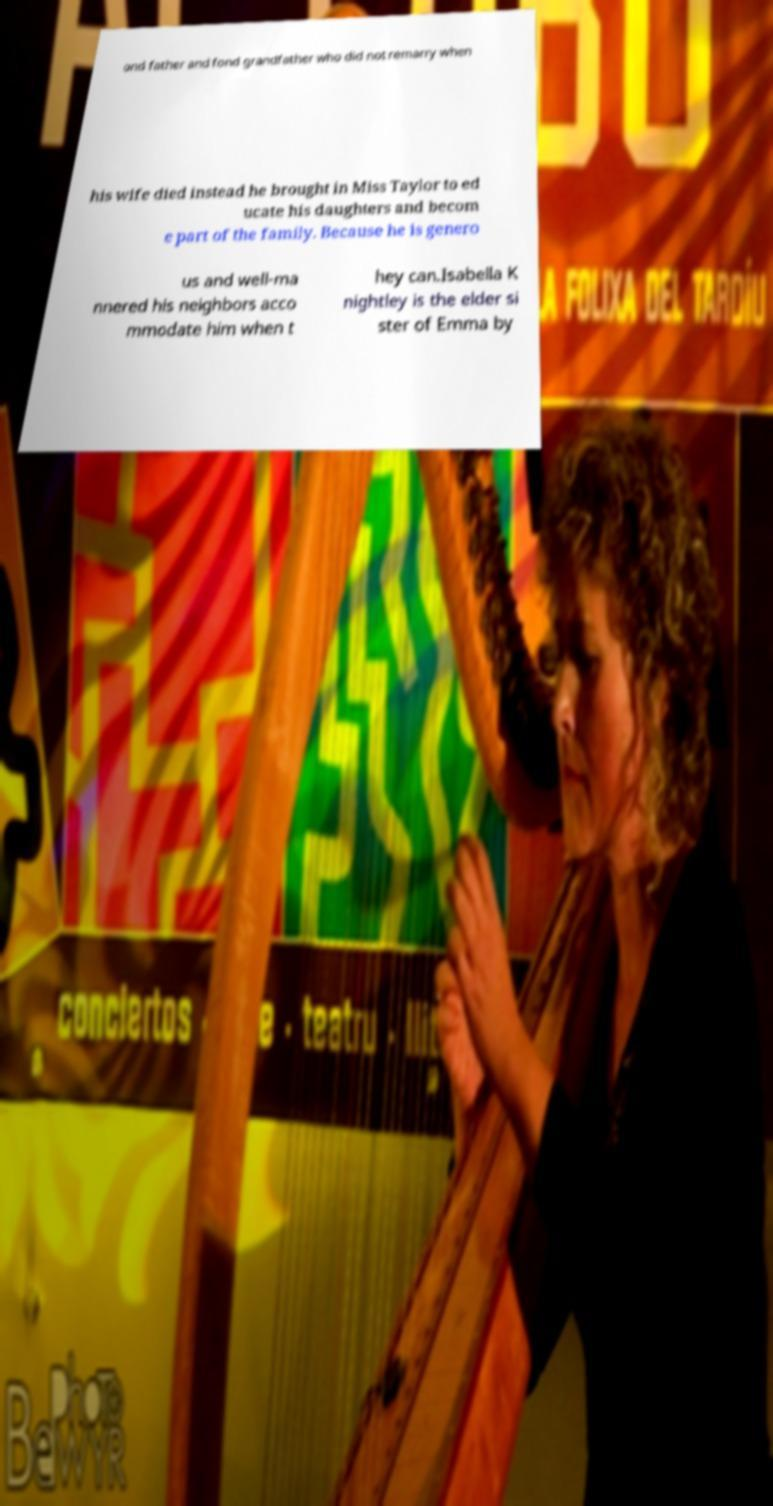Please read and relay the text visible in this image. What does it say? ond father and fond grandfather who did not remarry when his wife died instead he brought in Miss Taylor to ed ucate his daughters and becom e part of the family. Because he is genero us and well-ma nnered his neighbors acco mmodate him when t hey can.Isabella K nightley is the elder si ster of Emma by 